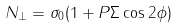<formula> <loc_0><loc_0><loc_500><loc_500>N _ { \perp } = { \sigma } _ { 0 } ( 1 + P \Sigma \cos 2 \phi )</formula> 